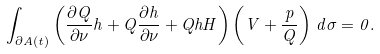<formula> <loc_0><loc_0><loc_500><loc_500>\int _ { \partial A ( t ) } \left ( \frac { \partial Q } { \partial \nu } h + Q \frac { \partial h } { \partial \nu } + Q h H \right ) \left ( V + \frac { p } { Q } \right ) \, d \sigma = 0 .</formula> 